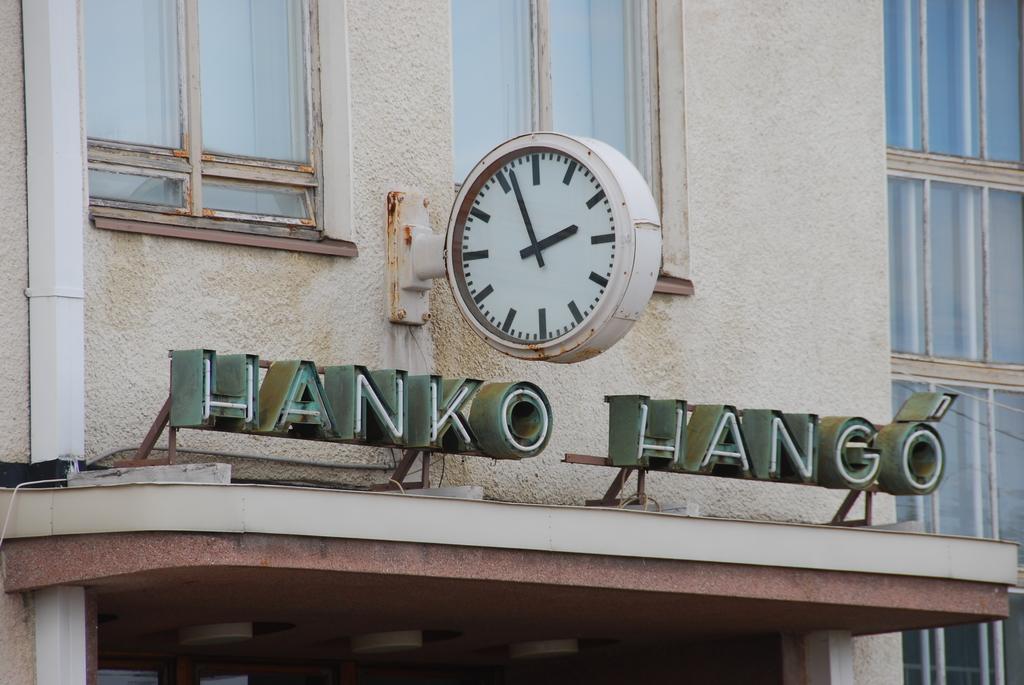Who is the owner of the building?
Offer a very short reply. Hanko hango. 